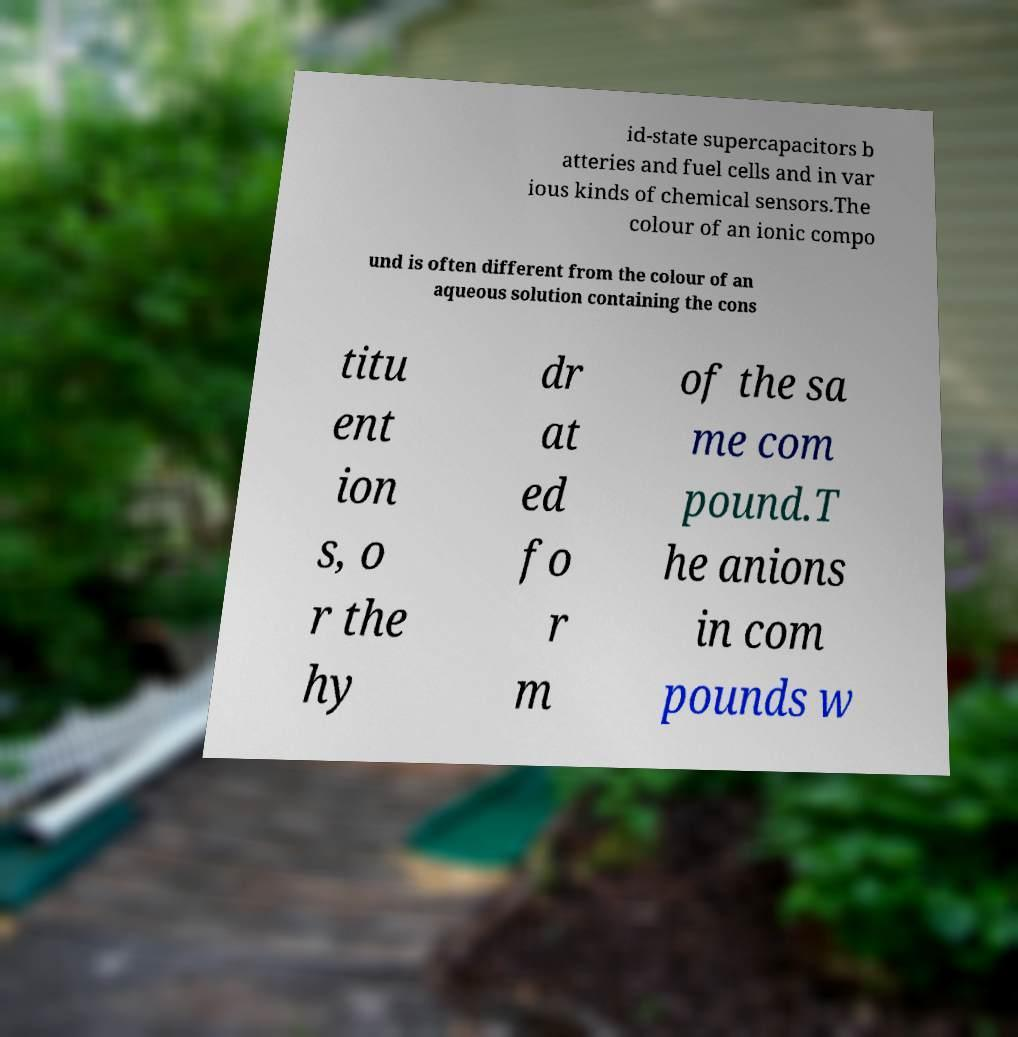Could you assist in decoding the text presented in this image and type it out clearly? id-state supercapacitors b atteries and fuel cells and in var ious kinds of chemical sensors.The colour of an ionic compo und is often different from the colour of an aqueous solution containing the cons titu ent ion s, o r the hy dr at ed fo r m of the sa me com pound.T he anions in com pounds w 